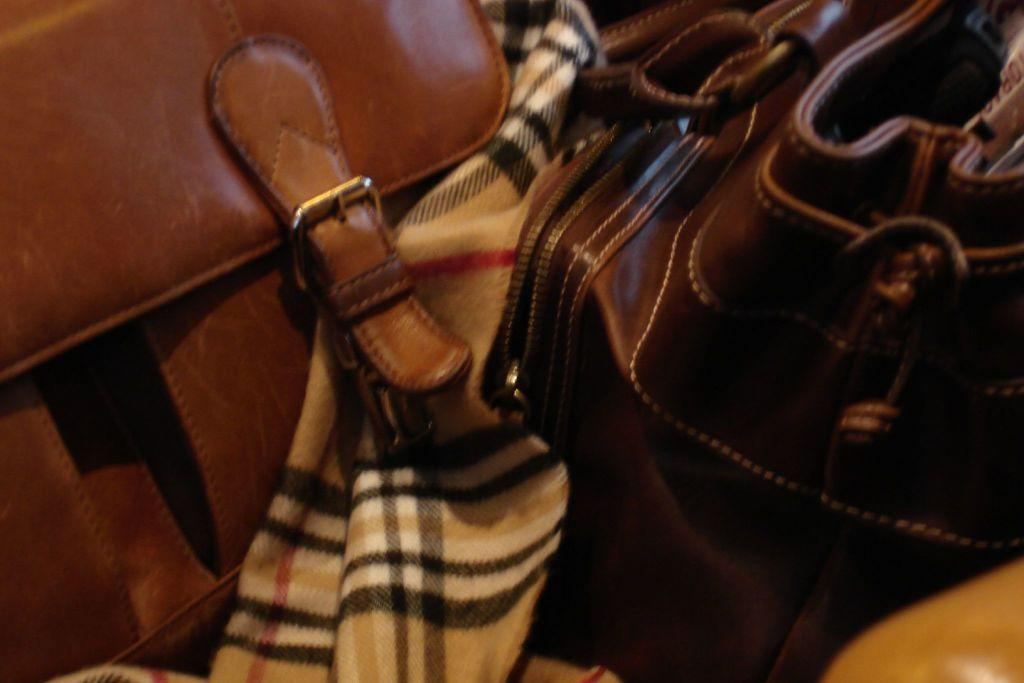What type of accessory can be seen in the image? There are handbags in the image. What other item is present in the image? There is a cloth in the image. What sense is being stimulated by the handbags in the image? The image does not provide information about any senses being stimulated by the handbags. 